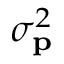<formula> <loc_0><loc_0><loc_500><loc_500>\sigma _ { p } ^ { 2 }</formula> 